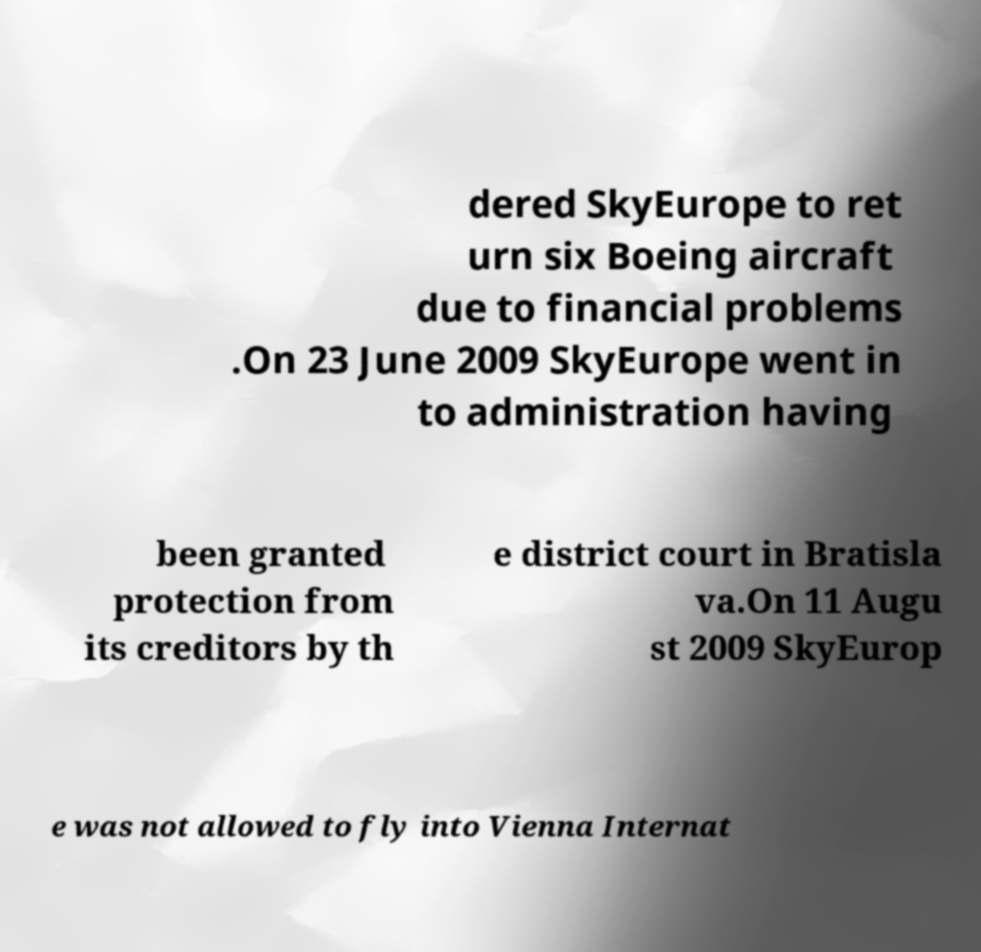Could you assist in decoding the text presented in this image and type it out clearly? dered SkyEurope to ret urn six Boeing aircraft due to financial problems .On 23 June 2009 SkyEurope went in to administration having been granted protection from its creditors by th e district court in Bratisla va.On 11 Augu st 2009 SkyEurop e was not allowed to fly into Vienna Internat 